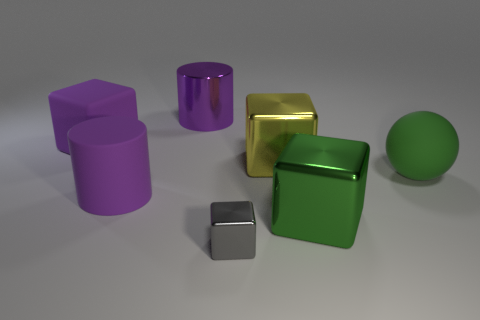There is a purple shiny cylinder that is behind the purple thing in front of the large yellow object; what number of big cylinders are to the left of it?
Your answer should be compact. 1. What is the shape of the big matte object that is to the right of the gray shiny cube?
Your answer should be compact. Sphere. How many other objects are the same material as the green sphere?
Make the answer very short. 2. Is the color of the big matte cylinder the same as the matte block?
Keep it short and to the point. Yes. Are there fewer big green metallic cubes in front of the tiny gray block than big purple objects that are in front of the purple metallic cylinder?
Keep it short and to the point. Yes. What is the color of the other rubber thing that is the same shape as the yellow object?
Keep it short and to the point. Purple. There is a sphere that is right of the purple cube; is its size the same as the tiny metal block?
Your answer should be compact. No. Is the number of gray shiny things behind the tiny gray object less than the number of green shiny spheres?
Make the answer very short. No. Is there anything else that is the same size as the gray block?
Provide a short and direct response. No. How big is the cylinder that is behind the big purple matte thing that is behind the large matte cylinder?
Provide a succinct answer. Large. 